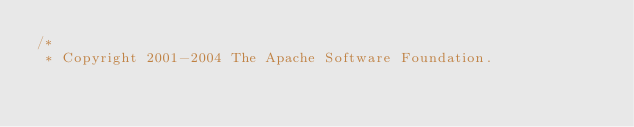<code> <loc_0><loc_0><loc_500><loc_500><_Java_>/*
 * Copyright 2001-2004 The Apache Software Foundation.</code> 